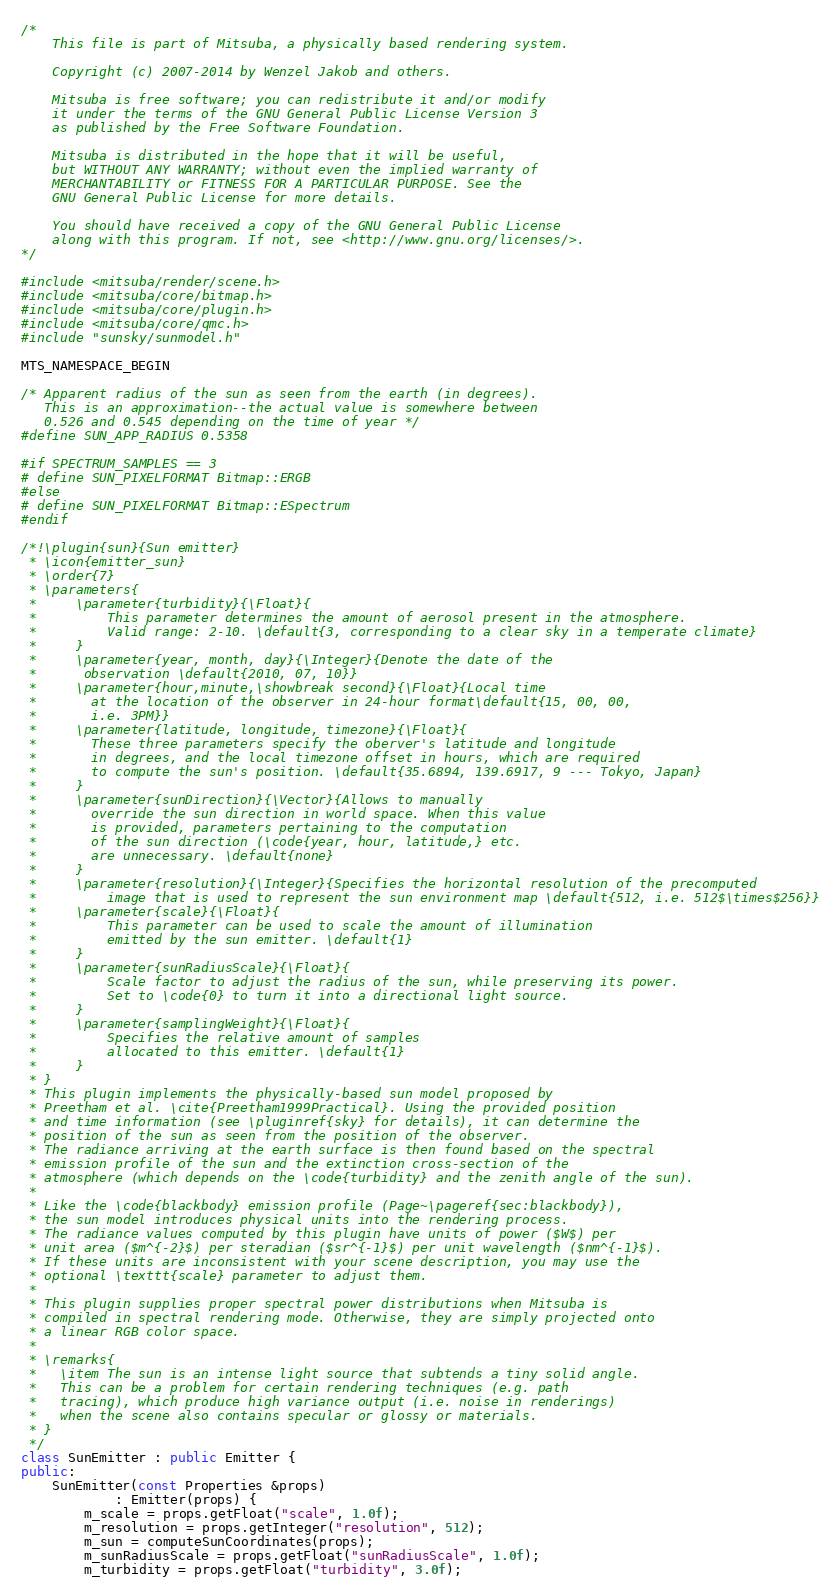<code> <loc_0><loc_0><loc_500><loc_500><_C++_>/*
	This file is part of Mitsuba, a physically based rendering system.

	Copyright (c) 2007-2014 by Wenzel Jakob and others.

	Mitsuba is free software; you can redistribute it and/or modify
	it under the terms of the GNU General Public License Version 3
	as published by the Free Software Foundation.

	Mitsuba is distributed in the hope that it will be useful,
	but WITHOUT ANY WARRANTY; without even the implied warranty of
	MERCHANTABILITY or FITNESS FOR A PARTICULAR PURPOSE. See the
	GNU General Public License for more details.

	You should have received a copy of the GNU General Public License
	along with this program. If not, see <http://www.gnu.org/licenses/>.
*/

#include <mitsuba/render/scene.h>
#include <mitsuba/core/bitmap.h>
#include <mitsuba/core/plugin.h>
#include <mitsuba/core/qmc.h>
#include "sunsky/sunmodel.h"

MTS_NAMESPACE_BEGIN

/* Apparent radius of the sun as seen from the earth (in degrees).
   This is an approximation--the actual value is somewhere between
   0.526 and 0.545 depending on the time of year */
#define SUN_APP_RADIUS 0.5358

#if SPECTRUM_SAMPLES == 3
# define SUN_PIXELFORMAT Bitmap::ERGB
#else
# define SUN_PIXELFORMAT Bitmap::ESpectrum
#endif

/*!\plugin{sun}{Sun emitter}
 * \icon{emitter_sun}
 * \order{7}
 * \parameters{
 *     \parameter{turbidity}{\Float}{
 *         This parameter determines the amount of aerosol present in the atmosphere.
 *         Valid range: 2-10. \default{3, corresponding to a clear sky in a temperate climate}
 *     }
 *     \parameter{year, month, day}{\Integer}{Denote the date of the
 *      observation \default{2010, 07, 10}}
 *     \parameter{hour,minute,\showbreak second}{\Float}{Local time
 *       at the location of the observer in 24-hour format\default{15, 00, 00,
 *       i.e. 3PM}}
 *     \parameter{latitude, longitude, timezone}{\Float}{
 *       These three parameters specify the oberver's latitude and longitude
 *       in degrees, and the local timezone offset in hours, which are required
 *       to compute the sun's position. \default{35.6894, 139.6917, 9 --- Tokyo, Japan}
 *     }
 *     \parameter{sunDirection}{\Vector}{Allows to manually
 *       override the sun direction in world space. When this value
 *       is provided, parameters pertaining to the computation
 *       of the sun direction (\code{year, hour, latitude,} etc.
 *       are unnecessary. \default{none}
 *     }
 *     \parameter{resolution}{\Integer}{Specifies the horizontal resolution of the precomputed
 *         image that is used to represent the sun environment map \default{512, i.e. 512$\times$256}}
 *     \parameter{scale}{\Float}{
 *         This parameter can be used to scale the amount of illumination
 *         emitted by the sun emitter. \default{1}
 *     }
 *     \parameter{sunRadiusScale}{\Float}{
 *         Scale factor to adjust the radius of the sun, while preserving its power.
 *         Set to \code{0} to turn it into a directional light source.
 *     }
 *     \parameter{samplingWeight}{\Float}{
 *         Specifies the relative amount of samples
 *         allocated to this emitter. \default{1}
 *     }
 * }
 * This plugin implements the physically-based sun model proposed by
 * Preetham et al. \cite{Preetham1999Practical}. Using the provided position
 * and time information (see \pluginref{sky} for details), it can determine the
 * position of the sun as seen from the position of the observer.
 * The radiance arriving at the earth surface is then found based on the spectral
 * emission profile of the sun and the extinction cross-section of the
 * atmosphere (which depends on the \code{turbidity} and the zenith angle of the sun).
 *
 * Like the \code{blackbody} emission profile (Page~\pageref{sec:blackbody}),
 * the sun model introduces physical units into the rendering process.
 * The radiance values computed by this plugin have units of power ($W$) per
 * unit area ($m^{-2}$) per steradian ($sr^{-1}$) per unit wavelength ($nm^{-1}$).
 * If these units are inconsistent with your scene description, you may use the
 * optional \texttt{scale} parameter to adjust them.
 *
 * This plugin supplies proper spectral power distributions when Mitsuba is
 * compiled in spectral rendering mode. Otherwise, they are simply projected onto
 * a linear RGB color space.
 *
 * \remarks{
 *   \item The sun is an intense light source that subtends a tiny solid angle.
 *   This can be a problem for certain rendering techniques (e.g. path
 *   tracing), which produce high variance output (i.e. noise in renderings)
 *   when the scene also contains specular or glossy or materials.
 * }
 */
class SunEmitter : public Emitter {
public:
	SunEmitter(const Properties &props)
			: Emitter(props) {
		m_scale = props.getFloat("scale", 1.0f);
		m_resolution = props.getInteger("resolution", 512);
		m_sun = computeSunCoordinates(props);
		m_sunRadiusScale = props.getFloat("sunRadiusScale", 1.0f);
		m_turbidity = props.getFloat("turbidity", 3.0f);</code> 